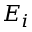<formula> <loc_0><loc_0><loc_500><loc_500>E _ { i }</formula> 